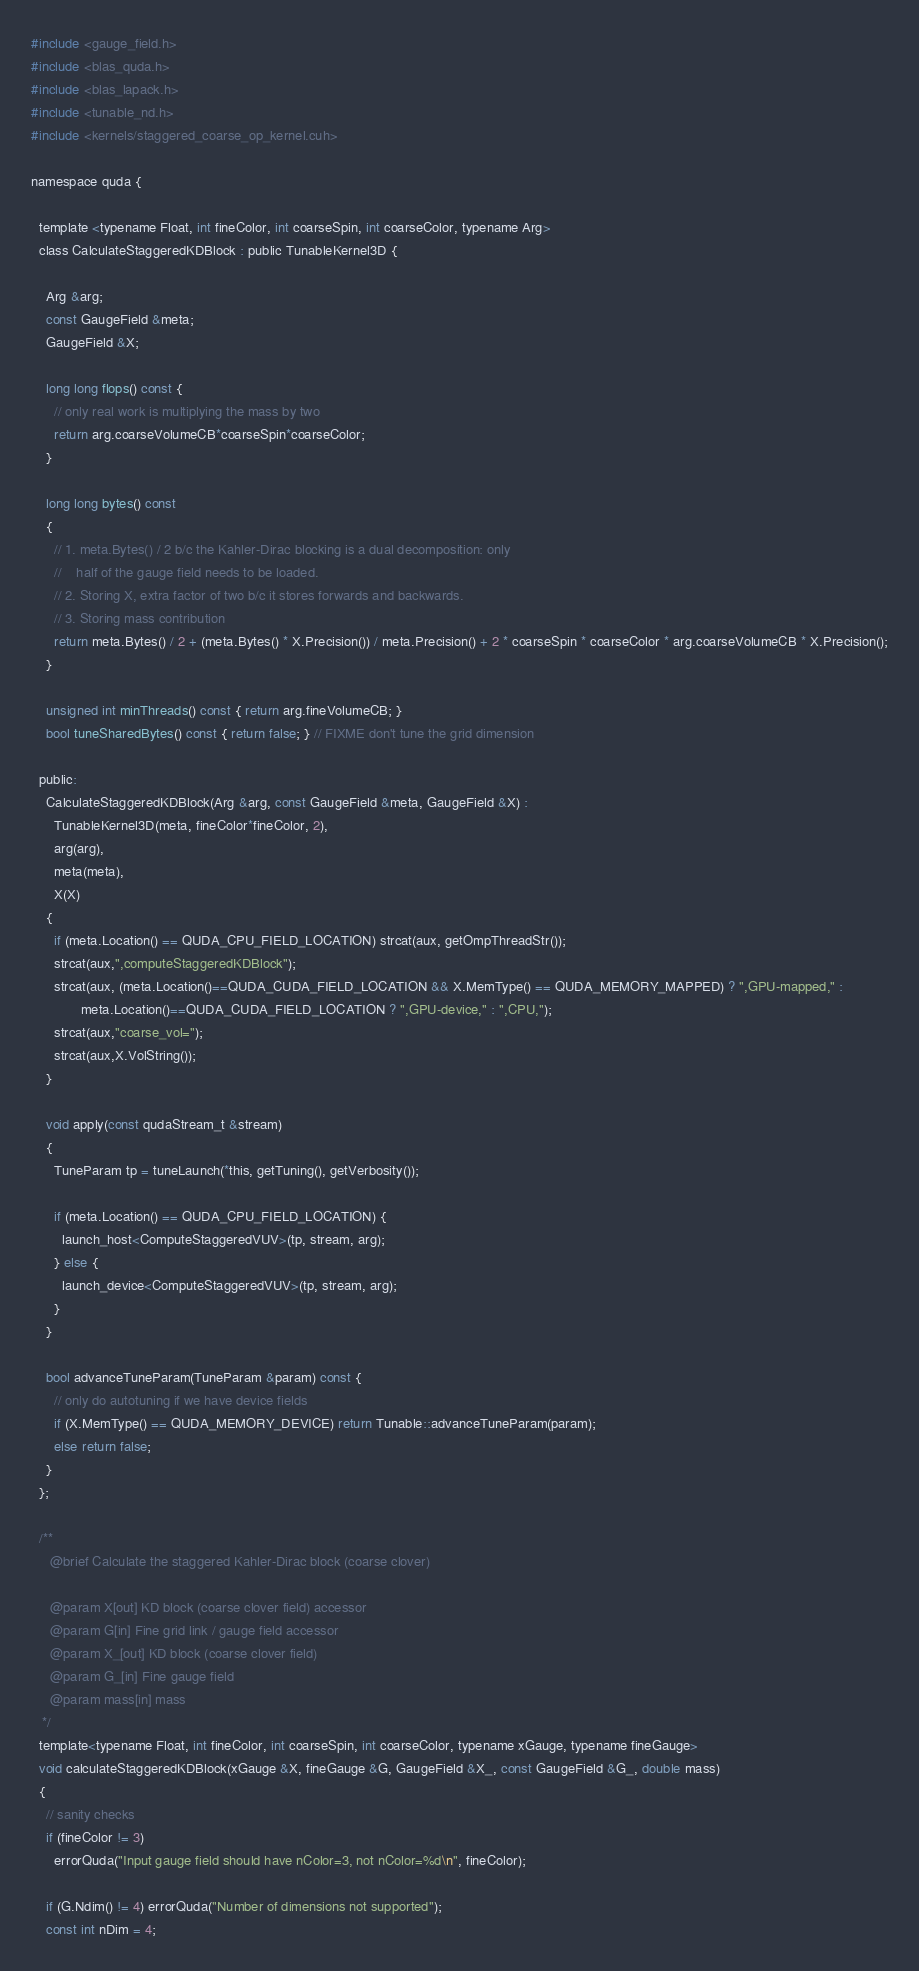<code> <loc_0><loc_0><loc_500><loc_500><_Cuda_>#include <gauge_field.h>
#include <blas_quda.h>
#include <blas_lapack.h>
#include <tunable_nd.h>
#include <kernels/staggered_coarse_op_kernel.cuh>

namespace quda {

  template <typename Float, int fineColor, int coarseSpin, int coarseColor, typename Arg>
  class CalculateStaggeredKDBlock : public TunableKernel3D {

    Arg &arg;
    const GaugeField &meta;
    GaugeField &X;

    long long flops() const { 
      // only real work is multiplying the mass by two
      return arg.coarseVolumeCB*coarseSpin*coarseColor;
    }

    long long bytes() const
    {
      // 1. meta.Bytes() / 2 b/c the Kahler-Dirac blocking is a dual decomposition: only
      //    half of the gauge field needs to be loaded.
      // 2. Storing X, extra factor of two b/c it stores forwards and backwards.
      // 3. Storing mass contribution
      return meta.Bytes() / 2 + (meta.Bytes() * X.Precision()) / meta.Precision() + 2 * coarseSpin * coarseColor * arg.coarseVolumeCB * X.Precision();
    }

    unsigned int minThreads() const { return arg.fineVolumeCB; }
    bool tuneSharedBytes() const { return false; } // FIXME don't tune the grid dimension

  public:
    CalculateStaggeredKDBlock(Arg &arg, const GaugeField &meta, GaugeField &X) :
      TunableKernel3D(meta, fineColor*fineColor, 2),
      arg(arg),
      meta(meta),
      X(X)
    {
      if (meta.Location() == QUDA_CPU_FIELD_LOCATION) strcat(aux, getOmpThreadStr());
      strcat(aux,",computeStaggeredKDBlock");
      strcat(aux, (meta.Location()==QUDA_CUDA_FIELD_LOCATION && X.MemType() == QUDA_MEMORY_MAPPED) ? ",GPU-mapped," :
             meta.Location()==QUDA_CUDA_FIELD_LOCATION ? ",GPU-device," : ",CPU,");
      strcat(aux,"coarse_vol=");
      strcat(aux,X.VolString());
    }

    void apply(const qudaStream_t &stream)
    {
      TuneParam tp = tuneLaunch(*this, getTuning(), getVerbosity());

      if (meta.Location() == QUDA_CPU_FIELD_LOCATION) {
        launch_host<ComputeStaggeredVUV>(tp, stream, arg);
      } else {
        launch_device<ComputeStaggeredVUV>(tp, stream, arg);
      }
    }

    bool advanceTuneParam(TuneParam &param) const {
      // only do autotuning if we have device fields
      if (X.MemType() == QUDA_MEMORY_DEVICE) return Tunable::advanceTuneParam(param);
      else return false;
    }
  };

  /**
     @brief Calculate the staggered Kahler-Dirac block (coarse clover)

     @param X[out] KD block (coarse clover field) accessor
     @param G[in] Fine grid link / gauge field accessor
     @param X_[out] KD block (coarse clover field)
     @param G_[in] Fine gauge field
     @param mass[in] mass
   */
  template<typename Float, int fineColor, int coarseSpin, int coarseColor, typename xGauge, typename fineGauge>
  void calculateStaggeredKDBlock(xGauge &X, fineGauge &G, GaugeField &X_, const GaugeField &G_, double mass)
  {
    // sanity checks
    if (fineColor != 3)
      errorQuda("Input gauge field should have nColor=3, not nColor=%d\n", fineColor);

    if (G.Ndim() != 4) errorQuda("Number of dimensions not supported");
    const int nDim = 4;
</code> 